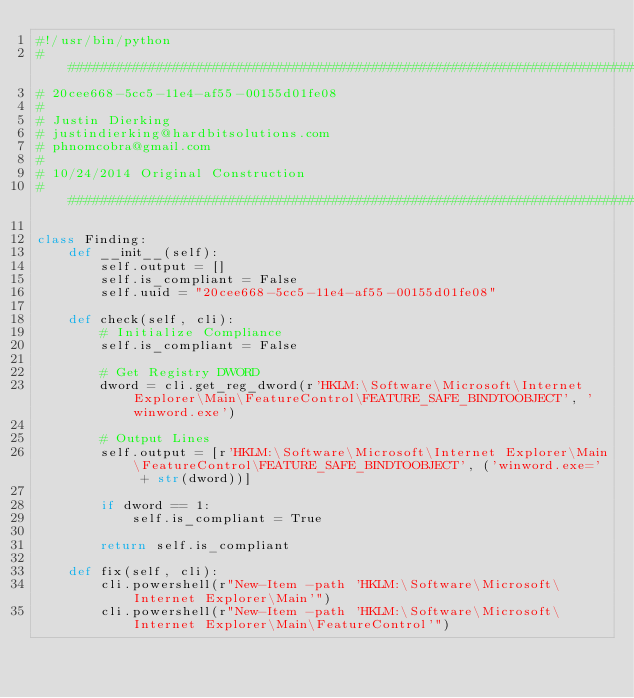<code> <loc_0><loc_0><loc_500><loc_500><_Python_>#!/usr/bin/python
################################################################################
# 20cee668-5cc5-11e4-af55-00155d01fe08
#
# Justin Dierking
# justindierking@hardbitsolutions.com
# phnomcobra@gmail.com
#
# 10/24/2014 Original Construction
################################################################################

class Finding:
    def __init__(self):
        self.output = []
        self.is_compliant = False
        self.uuid = "20cee668-5cc5-11e4-af55-00155d01fe08"
        
    def check(self, cli):
        # Initialize Compliance
        self.is_compliant = False

        # Get Registry DWORD
        dword = cli.get_reg_dword(r'HKLM:\Software\Microsoft\Internet Explorer\Main\FeatureControl\FEATURE_SAFE_BINDTOOBJECT', 'winword.exe')

        # Output Lines
        self.output = [r'HKLM:\Software\Microsoft\Internet Explorer\Main\FeatureControl\FEATURE_SAFE_BINDTOOBJECT', ('winword.exe=' + str(dword))]

        if dword == 1:
            self.is_compliant = True

        return self.is_compliant

    def fix(self, cli):
        cli.powershell(r"New-Item -path 'HKLM:\Software\Microsoft\Internet Explorer\Main'")
        cli.powershell(r"New-Item -path 'HKLM:\Software\Microsoft\Internet Explorer\Main\FeatureControl'")</code> 